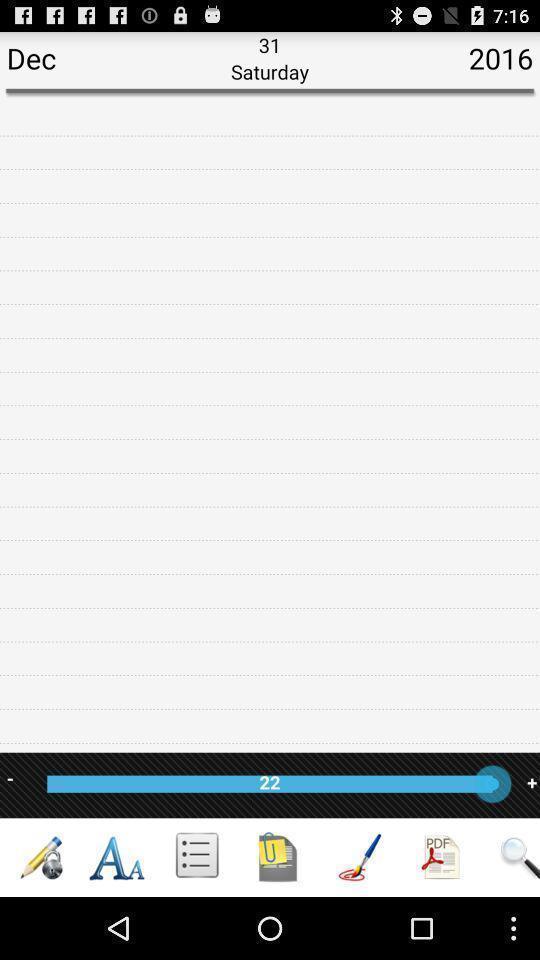Summarize the main components in this picture. Pop up displaying about the calendar and note. 